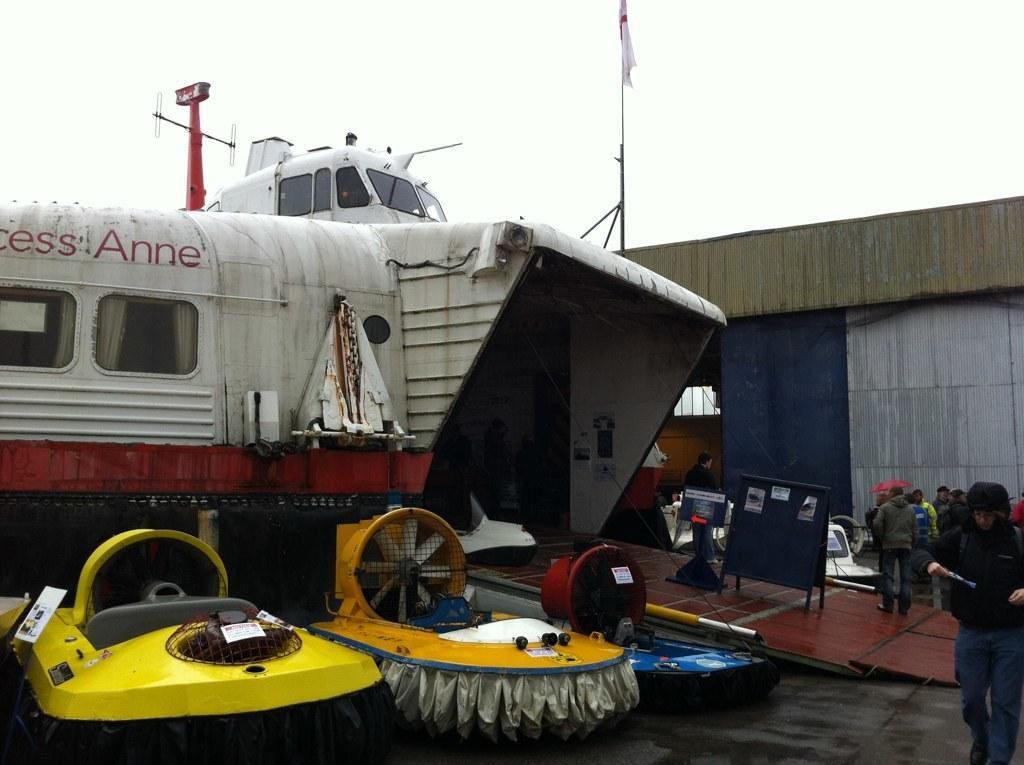How would you summarize this image in a sentence or two? In the foreground of the picture there are some vehicles and other objects. On the right there is a person walking. In the center of the right there are people, board and vehicle. At the top there is a flag and we can see sky. In the center of the picture towards right there is a building. 